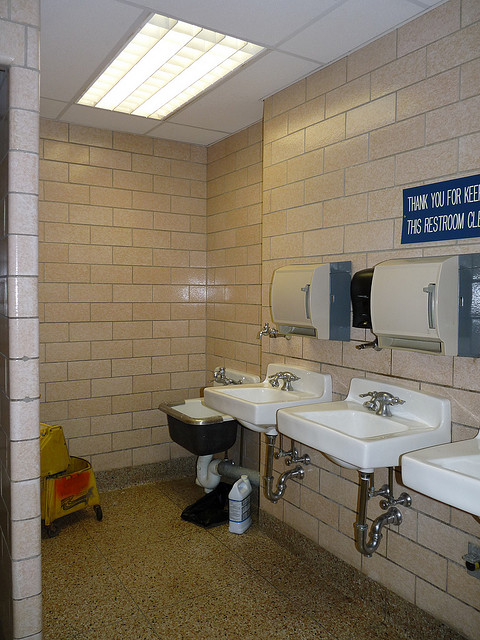Is there more than one sink? Yes, there are multiple sinks available in the restroom, which allows for simultaneous use by several people. 